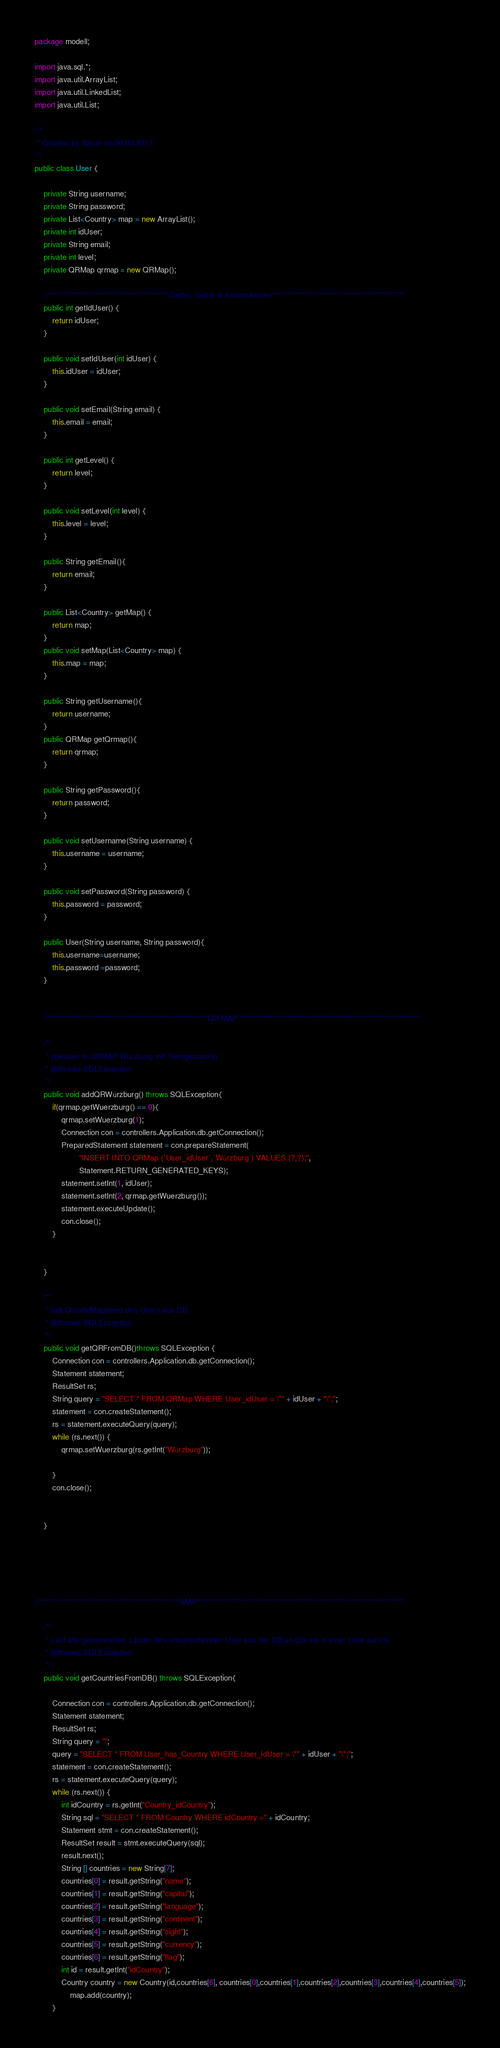<code> <loc_0><loc_0><loc_500><loc_500><_Java_>package modell;

import java.sql.*;
import java.util.ArrayList;
import java.util.LinkedList;
import java.util.List;

/**
 * Created by Sarah on 06.03.2017.
 */
public class User {

    private String username;
    private String password;
    private List<Country> map = new ArrayList();
    private int idUser;
    private String email;
    private int level;
    private QRMap qrmap = new QRMap();

    //*****************************************Getter, Setter & Konstruktoren*********************************************
    public int getIdUser() {
        return idUser;
    }

    public void setIdUser(int idUser) {
        this.idUser = idUser;
    }

    public void setEmail(String email) {
        this.email = email;
    }

    public int getLevel() {
        return level;
    }

    public void setLevel(int level) {
        this.level = level;
    }

    public String getEmail(){
        return email;
    }

    public List<Country> getMap() {
        return map;
    }
    public void setMap(List<Country> map) {
        this.map = map;
    }

    public String getUsername(){
        return username;
    }
    public QRMap getQrmap(){
        return qrmap;
    }

    public String getPassword(){
        return password;
    }

    public void setUsername(String username) {
        this.username = username;
    }

    public void setPassword(String password) {
        this.password = password;
    }

    public User(String username, String password){
        this.username=username;
        this.password =password;
    }


    //******************************************************QR MAP *************************************************************

    /**
     * speicher in QRMAP Würzburg mit 1(eingescannt)
     * @throws SQLException
     */
    public void addQRWürzburg() throws SQLException{
        if(qrmap.getWuerzburg() == 0){
            qrmap.setWuerzburg(1);
            Connection con = controllers.Application.db.getConnection();
            PreparedStatement statement = con.prepareStatement(
                    "INSERT INTO QRMap (`User_idUser`,`Würzburg`) VALUES (?,?);",
                    Statement.RETURN_GENERATED_KEYS);
            statement.setInt(1, idUser);
            statement.setInt(2, qrmap.getWuerzburg());
            statement.executeUpdate();
            con.close();
        }


    }

    /**
     * lädt QrcodeMapstand des Users aus DB
     * @throws SQLException
     */
    public void getQRFromDB()throws SQLException {
        Connection con = controllers.Application.db.getConnection();
        Statement statement;
        ResultSet rs;
        String query = "SELECT * FROM QRMap WHERE User_idUser = \"" + idUser + "\";";
        statement = con.createStatement();
        rs = statement.executeQuery(query);
        while (rs.next()) {
            qrmap.setWuerzburg(rs.getInt("Würzburg"));

        }
        con.close();


    }





//************************************************MAP**********************************************************************

    /**
     * Lädt alle gesammelten Länder des entsprechenden User aus der DB un gibt sie in einer Liste zurück
     * @throws SQLException
     */
    public void getCountriesFromDB() throws SQLException{

        Connection con = controllers.Application.db.getConnection();
        Statement statement;
        ResultSet rs;
        String query = "";
        query = "SELECT * FROM User_has_Country WHERE User_idUser = \"" + idUser + "\";";
        statement = con.createStatement();
        rs = statement.executeQuery(query);
        while (rs.next()) {
            int idCountry = rs.getInt("Country_idCountry");
            String sql = "SELECT * FROM Country WHERE idCountry =" + idCountry;
            Statement stmt = con.createStatement();
            ResultSet result = stmt.executeQuery(sql);
            result.next();
            String [] countries = new String[7];
            countries[0] = result.getString("name");
            countries[1] = result.getString("capital");
            countries[2] = result.getString("language");
            countries[3] = result.getString("continent");
            countries[4] = result.getString("sight");
            countries[5] = result.getString("currency");
            countries[6] = result.getString("flag");
            int id = result.getInt("idCountry");
            Country country = new Country(id,countries[6], countries[0],countries[1],countries[2],countries[3],countries[4],countries[5]);
                map.add(country);
        }</code> 